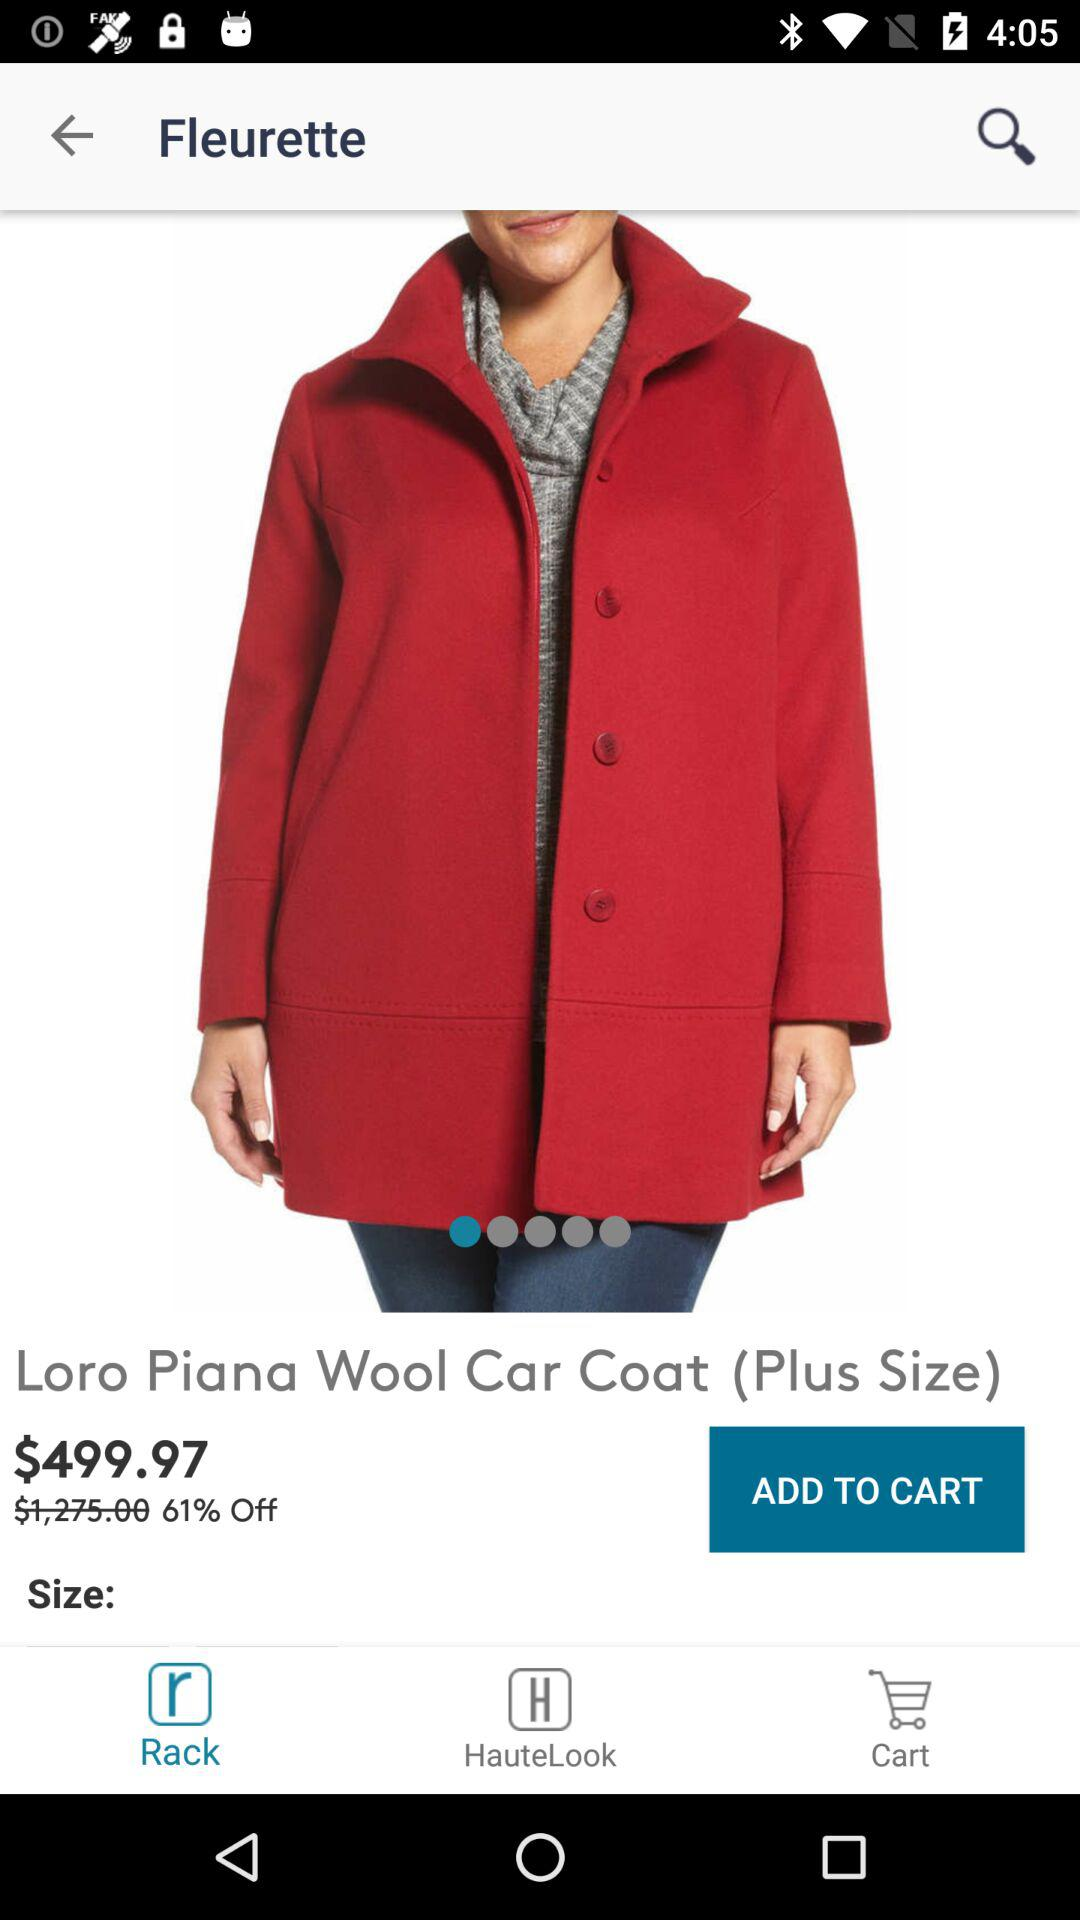How much discount is available on the product? The available discount is 61%. 